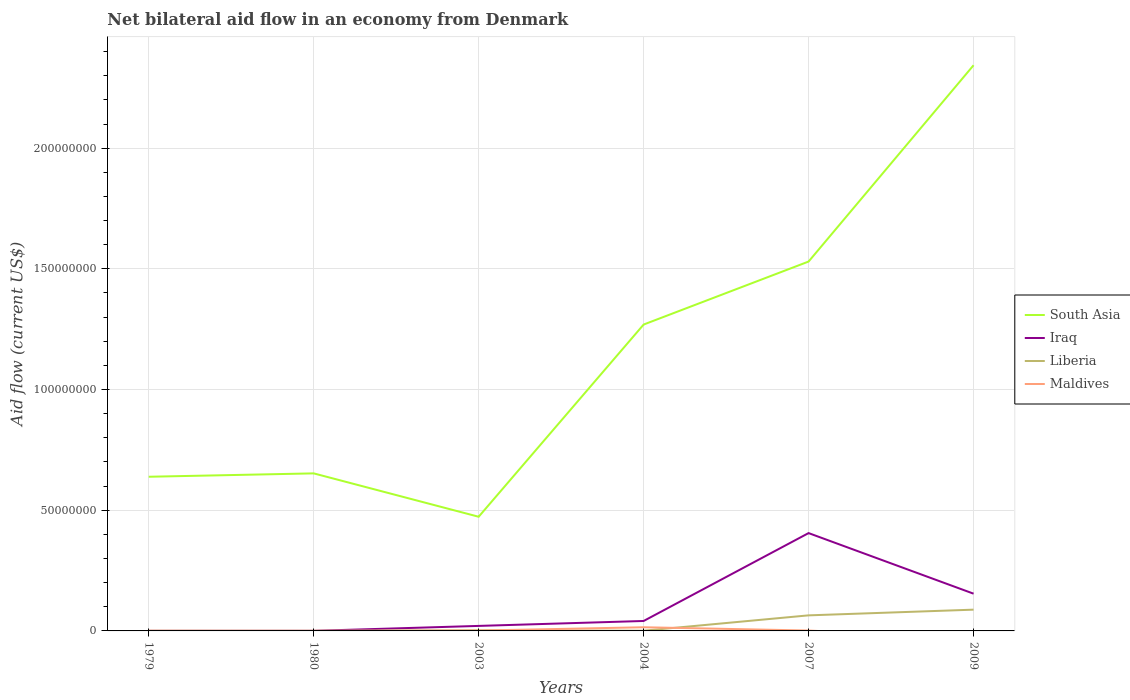Is the number of lines equal to the number of legend labels?
Offer a terse response. No. Across all years, what is the maximum net bilateral aid flow in Iraq?
Offer a terse response. 2.00e+04. What is the total net bilateral aid flow in Liberia in the graph?
Ensure brevity in your answer.  -8.56e+06. What is the difference between the highest and the second highest net bilateral aid flow in South Asia?
Give a very brief answer. 1.87e+08. Is the net bilateral aid flow in Maldives strictly greater than the net bilateral aid flow in South Asia over the years?
Make the answer very short. Yes. How many years are there in the graph?
Make the answer very short. 6. Where does the legend appear in the graph?
Your response must be concise. Center right. How are the legend labels stacked?
Your answer should be compact. Vertical. What is the title of the graph?
Keep it short and to the point. Net bilateral aid flow in an economy from Denmark. What is the Aid flow (current US$) in South Asia in 1979?
Provide a short and direct response. 6.39e+07. What is the Aid flow (current US$) of Iraq in 1979?
Make the answer very short. 2.00e+04. What is the Aid flow (current US$) in Liberia in 1979?
Give a very brief answer. 3.00e+04. What is the Aid flow (current US$) of South Asia in 1980?
Offer a terse response. 6.53e+07. What is the Aid flow (current US$) in Maldives in 1980?
Ensure brevity in your answer.  4.00e+04. What is the Aid flow (current US$) in South Asia in 2003?
Make the answer very short. 4.73e+07. What is the Aid flow (current US$) of Iraq in 2003?
Offer a very short reply. 2.08e+06. What is the Aid flow (current US$) of Liberia in 2003?
Provide a succinct answer. 2.50e+05. What is the Aid flow (current US$) of South Asia in 2004?
Your answer should be very brief. 1.27e+08. What is the Aid flow (current US$) in Iraq in 2004?
Provide a succinct answer. 4.12e+06. What is the Aid flow (current US$) of Maldives in 2004?
Offer a very short reply. 1.52e+06. What is the Aid flow (current US$) in South Asia in 2007?
Ensure brevity in your answer.  1.53e+08. What is the Aid flow (current US$) of Iraq in 2007?
Offer a very short reply. 4.05e+07. What is the Aid flow (current US$) in Liberia in 2007?
Offer a terse response. 6.45e+06. What is the Aid flow (current US$) in Maldives in 2007?
Offer a very short reply. 1.60e+05. What is the Aid flow (current US$) of South Asia in 2009?
Ensure brevity in your answer.  2.34e+08. What is the Aid flow (current US$) in Iraq in 2009?
Your response must be concise. 1.54e+07. What is the Aid flow (current US$) in Liberia in 2009?
Your response must be concise. 8.81e+06. What is the Aid flow (current US$) of Maldives in 2009?
Your answer should be very brief. 0. Across all years, what is the maximum Aid flow (current US$) of South Asia?
Keep it short and to the point. 2.34e+08. Across all years, what is the maximum Aid flow (current US$) of Iraq?
Offer a very short reply. 4.05e+07. Across all years, what is the maximum Aid flow (current US$) of Liberia?
Provide a succinct answer. 8.81e+06. Across all years, what is the maximum Aid flow (current US$) in Maldives?
Your answer should be compact. 1.52e+06. Across all years, what is the minimum Aid flow (current US$) of South Asia?
Provide a short and direct response. 4.73e+07. Across all years, what is the minimum Aid flow (current US$) of Liberia?
Offer a very short reply. 2.00e+04. What is the total Aid flow (current US$) in South Asia in the graph?
Your answer should be very brief. 6.91e+08. What is the total Aid flow (current US$) of Iraq in the graph?
Offer a terse response. 6.22e+07. What is the total Aid flow (current US$) of Liberia in the graph?
Ensure brevity in your answer.  1.56e+07. What is the total Aid flow (current US$) in Maldives in the graph?
Your answer should be very brief. 1.93e+06. What is the difference between the Aid flow (current US$) of South Asia in 1979 and that in 1980?
Give a very brief answer. -1.40e+06. What is the difference between the Aid flow (current US$) of Maldives in 1979 and that in 1980?
Make the answer very short. 3.00e+04. What is the difference between the Aid flow (current US$) in South Asia in 1979 and that in 2003?
Make the answer very short. 1.66e+07. What is the difference between the Aid flow (current US$) of Iraq in 1979 and that in 2003?
Provide a succinct answer. -2.06e+06. What is the difference between the Aid flow (current US$) in Liberia in 1979 and that in 2003?
Offer a very short reply. -2.20e+05. What is the difference between the Aid flow (current US$) of Maldives in 1979 and that in 2003?
Make the answer very short. -7.00e+04. What is the difference between the Aid flow (current US$) in South Asia in 1979 and that in 2004?
Ensure brevity in your answer.  -6.31e+07. What is the difference between the Aid flow (current US$) in Iraq in 1979 and that in 2004?
Keep it short and to the point. -4.10e+06. What is the difference between the Aid flow (current US$) in Maldives in 1979 and that in 2004?
Give a very brief answer. -1.45e+06. What is the difference between the Aid flow (current US$) of South Asia in 1979 and that in 2007?
Provide a short and direct response. -8.92e+07. What is the difference between the Aid flow (current US$) in Iraq in 1979 and that in 2007?
Your answer should be compact. -4.05e+07. What is the difference between the Aid flow (current US$) of Liberia in 1979 and that in 2007?
Make the answer very short. -6.42e+06. What is the difference between the Aid flow (current US$) in Maldives in 1979 and that in 2007?
Provide a succinct answer. -9.00e+04. What is the difference between the Aid flow (current US$) in South Asia in 1979 and that in 2009?
Provide a short and direct response. -1.70e+08. What is the difference between the Aid flow (current US$) in Iraq in 1979 and that in 2009?
Ensure brevity in your answer.  -1.54e+07. What is the difference between the Aid flow (current US$) of Liberia in 1979 and that in 2009?
Ensure brevity in your answer.  -8.78e+06. What is the difference between the Aid flow (current US$) of South Asia in 1980 and that in 2003?
Make the answer very short. 1.80e+07. What is the difference between the Aid flow (current US$) of Iraq in 1980 and that in 2003?
Keep it short and to the point. -2.05e+06. What is the difference between the Aid flow (current US$) of Liberia in 1980 and that in 2003?
Offer a very short reply. -2.30e+05. What is the difference between the Aid flow (current US$) in South Asia in 1980 and that in 2004?
Offer a terse response. -6.17e+07. What is the difference between the Aid flow (current US$) of Iraq in 1980 and that in 2004?
Your answer should be very brief. -4.09e+06. What is the difference between the Aid flow (current US$) of Maldives in 1980 and that in 2004?
Keep it short and to the point. -1.48e+06. What is the difference between the Aid flow (current US$) in South Asia in 1980 and that in 2007?
Your response must be concise. -8.78e+07. What is the difference between the Aid flow (current US$) of Iraq in 1980 and that in 2007?
Offer a very short reply. -4.05e+07. What is the difference between the Aid flow (current US$) in Liberia in 1980 and that in 2007?
Keep it short and to the point. -6.43e+06. What is the difference between the Aid flow (current US$) of South Asia in 1980 and that in 2009?
Ensure brevity in your answer.  -1.69e+08. What is the difference between the Aid flow (current US$) of Iraq in 1980 and that in 2009?
Provide a short and direct response. -1.54e+07. What is the difference between the Aid flow (current US$) in Liberia in 1980 and that in 2009?
Provide a short and direct response. -8.79e+06. What is the difference between the Aid flow (current US$) in South Asia in 2003 and that in 2004?
Offer a terse response. -7.96e+07. What is the difference between the Aid flow (current US$) of Iraq in 2003 and that in 2004?
Your answer should be very brief. -2.04e+06. What is the difference between the Aid flow (current US$) of Liberia in 2003 and that in 2004?
Keep it short and to the point. 1.60e+05. What is the difference between the Aid flow (current US$) of Maldives in 2003 and that in 2004?
Your response must be concise. -1.38e+06. What is the difference between the Aid flow (current US$) in South Asia in 2003 and that in 2007?
Provide a succinct answer. -1.06e+08. What is the difference between the Aid flow (current US$) of Iraq in 2003 and that in 2007?
Your answer should be compact. -3.84e+07. What is the difference between the Aid flow (current US$) of Liberia in 2003 and that in 2007?
Offer a very short reply. -6.20e+06. What is the difference between the Aid flow (current US$) of South Asia in 2003 and that in 2009?
Keep it short and to the point. -1.87e+08. What is the difference between the Aid flow (current US$) of Iraq in 2003 and that in 2009?
Offer a terse response. -1.34e+07. What is the difference between the Aid flow (current US$) of Liberia in 2003 and that in 2009?
Your answer should be very brief. -8.56e+06. What is the difference between the Aid flow (current US$) of South Asia in 2004 and that in 2007?
Offer a terse response. -2.61e+07. What is the difference between the Aid flow (current US$) in Iraq in 2004 and that in 2007?
Ensure brevity in your answer.  -3.64e+07. What is the difference between the Aid flow (current US$) in Liberia in 2004 and that in 2007?
Offer a very short reply. -6.36e+06. What is the difference between the Aid flow (current US$) in Maldives in 2004 and that in 2007?
Your response must be concise. 1.36e+06. What is the difference between the Aid flow (current US$) in South Asia in 2004 and that in 2009?
Give a very brief answer. -1.07e+08. What is the difference between the Aid flow (current US$) of Iraq in 2004 and that in 2009?
Provide a short and direct response. -1.13e+07. What is the difference between the Aid flow (current US$) of Liberia in 2004 and that in 2009?
Offer a very short reply. -8.72e+06. What is the difference between the Aid flow (current US$) of South Asia in 2007 and that in 2009?
Give a very brief answer. -8.13e+07. What is the difference between the Aid flow (current US$) of Iraq in 2007 and that in 2009?
Ensure brevity in your answer.  2.51e+07. What is the difference between the Aid flow (current US$) in Liberia in 2007 and that in 2009?
Provide a succinct answer. -2.36e+06. What is the difference between the Aid flow (current US$) of South Asia in 1979 and the Aid flow (current US$) of Iraq in 1980?
Keep it short and to the point. 6.38e+07. What is the difference between the Aid flow (current US$) in South Asia in 1979 and the Aid flow (current US$) in Liberia in 1980?
Ensure brevity in your answer.  6.38e+07. What is the difference between the Aid flow (current US$) of South Asia in 1979 and the Aid flow (current US$) of Maldives in 1980?
Give a very brief answer. 6.38e+07. What is the difference between the Aid flow (current US$) in Liberia in 1979 and the Aid flow (current US$) in Maldives in 1980?
Your answer should be very brief. -10000. What is the difference between the Aid flow (current US$) of South Asia in 1979 and the Aid flow (current US$) of Iraq in 2003?
Offer a very short reply. 6.18e+07. What is the difference between the Aid flow (current US$) of South Asia in 1979 and the Aid flow (current US$) of Liberia in 2003?
Keep it short and to the point. 6.36e+07. What is the difference between the Aid flow (current US$) of South Asia in 1979 and the Aid flow (current US$) of Maldives in 2003?
Your answer should be very brief. 6.37e+07. What is the difference between the Aid flow (current US$) of South Asia in 1979 and the Aid flow (current US$) of Iraq in 2004?
Your answer should be compact. 5.98e+07. What is the difference between the Aid flow (current US$) of South Asia in 1979 and the Aid flow (current US$) of Liberia in 2004?
Provide a short and direct response. 6.38e+07. What is the difference between the Aid flow (current US$) of South Asia in 1979 and the Aid flow (current US$) of Maldives in 2004?
Your answer should be very brief. 6.24e+07. What is the difference between the Aid flow (current US$) in Iraq in 1979 and the Aid flow (current US$) in Liberia in 2004?
Keep it short and to the point. -7.00e+04. What is the difference between the Aid flow (current US$) of Iraq in 1979 and the Aid flow (current US$) of Maldives in 2004?
Your response must be concise. -1.50e+06. What is the difference between the Aid flow (current US$) of Liberia in 1979 and the Aid flow (current US$) of Maldives in 2004?
Make the answer very short. -1.49e+06. What is the difference between the Aid flow (current US$) of South Asia in 1979 and the Aid flow (current US$) of Iraq in 2007?
Give a very brief answer. 2.33e+07. What is the difference between the Aid flow (current US$) in South Asia in 1979 and the Aid flow (current US$) in Liberia in 2007?
Provide a short and direct response. 5.74e+07. What is the difference between the Aid flow (current US$) in South Asia in 1979 and the Aid flow (current US$) in Maldives in 2007?
Give a very brief answer. 6.37e+07. What is the difference between the Aid flow (current US$) of Iraq in 1979 and the Aid flow (current US$) of Liberia in 2007?
Your response must be concise. -6.43e+06. What is the difference between the Aid flow (current US$) of South Asia in 1979 and the Aid flow (current US$) of Iraq in 2009?
Your answer should be very brief. 4.84e+07. What is the difference between the Aid flow (current US$) of South Asia in 1979 and the Aid flow (current US$) of Liberia in 2009?
Your response must be concise. 5.51e+07. What is the difference between the Aid flow (current US$) in Iraq in 1979 and the Aid flow (current US$) in Liberia in 2009?
Offer a very short reply. -8.79e+06. What is the difference between the Aid flow (current US$) of South Asia in 1980 and the Aid flow (current US$) of Iraq in 2003?
Your answer should be compact. 6.32e+07. What is the difference between the Aid flow (current US$) in South Asia in 1980 and the Aid flow (current US$) in Liberia in 2003?
Your answer should be very brief. 6.50e+07. What is the difference between the Aid flow (current US$) in South Asia in 1980 and the Aid flow (current US$) in Maldives in 2003?
Ensure brevity in your answer.  6.51e+07. What is the difference between the Aid flow (current US$) in Iraq in 1980 and the Aid flow (current US$) in Liberia in 2003?
Provide a short and direct response. -2.20e+05. What is the difference between the Aid flow (current US$) of Iraq in 1980 and the Aid flow (current US$) of Maldives in 2003?
Provide a short and direct response. -1.10e+05. What is the difference between the Aid flow (current US$) of South Asia in 1980 and the Aid flow (current US$) of Iraq in 2004?
Your answer should be compact. 6.12e+07. What is the difference between the Aid flow (current US$) in South Asia in 1980 and the Aid flow (current US$) in Liberia in 2004?
Provide a short and direct response. 6.52e+07. What is the difference between the Aid flow (current US$) in South Asia in 1980 and the Aid flow (current US$) in Maldives in 2004?
Offer a very short reply. 6.38e+07. What is the difference between the Aid flow (current US$) in Iraq in 1980 and the Aid flow (current US$) in Maldives in 2004?
Make the answer very short. -1.49e+06. What is the difference between the Aid flow (current US$) in Liberia in 1980 and the Aid flow (current US$) in Maldives in 2004?
Provide a short and direct response. -1.50e+06. What is the difference between the Aid flow (current US$) in South Asia in 1980 and the Aid flow (current US$) in Iraq in 2007?
Keep it short and to the point. 2.47e+07. What is the difference between the Aid flow (current US$) of South Asia in 1980 and the Aid flow (current US$) of Liberia in 2007?
Ensure brevity in your answer.  5.88e+07. What is the difference between the Aid flow (current US$) of South Asia in 1980 and the Aid flow (current US$) of Maldives in 2007?
Ensure brevity in your answer.  6.51e+07. What is the difference between the Aid flow (current US$) in Iraq in 1980 and the Aid flow (current US$) in Liberia in 2007?
Your response must be concise. -6.42e+06. What is the difference between the Aid flow (current US$) in Iraq in 1980 and the Aid flow (current US$) in Maldives in 2007?
Make the answer very short. -1.30e+05. What is the difference between the Aid flow (current US$) in Liberia in 1980 and the Aid flow (current US$) in Maldives in 2007?
Make the answer very short. -1.40e+05. What is the difference between the Aid flow (current US$) in South Asia in 1980 and the Aid flow (current US$) in Iraq in 2009?
Make the answer very short. 4.98e+07. What is the difference between the Aid flow (current US$) in South Asia in 1980 and the Aid flow (current US$) in Liberia in 2009?
Provide a succinct answer. 5.65e+07. What is the difference between the Aid flow (current US$) of Iraq in 1980 and the Aid flow (current US$) of Liberia in 2009?
Offer a terse response. -8.78e+06. What is the difference between the Aid flow (current US$) in South Asia in 2003 and the Aid flow (current US$) in Iraq in 2004?
Keep it short and to the point. 4.32e+07. What is the difference between the Aid flow (current US$) of South Asia in 2003 and the Aid flow (current US$) of Liberia in 2004?
Provide a succinct answer. 4.72e+07. What is the difference between the Aid flow (current US$) in South Asia in 2003 and the Aid flow (current US$) in Maldives in 2004?
Provide a short and direct response. 4.58e+07. What is the difference between the Aid flow (current US$) in Iraq in 2003 and the Aid flow (current US$) in Liberia in 2004?
Your response must be concise. 1.99e+06. What is the difference between the Aid flow (current US$) of Iraq in 2003 and the Aid flow (current US$) of Maldives in 2004?
Keep it short and to the point. 5.60e+05. What is the difference between the Aid flow (current US$) of Liberia in 2003 and the Aid flow (current US$) of Maldives in 2004?
Ensure brevity in your answer.  -1.27e+06. What is the difference between the Aid flow (current US$) of South Asia in 2003 and the Aid flow (current US$) of Iraq in 2007?
Give a very brief answer. 6.77e+06. What is the difference between the Aid flow (current US$) of South Asia in 2003 and the Aid flow (current US$) of Liberia in 2007?
Your answer should be compact. 4.08e+07. What is the difference between the Aid flow (current US$) in South Asia in 2003 and the Aid flow (current US$) in Maldives in 2007?
Ensure brevity in your answer.  4.71e+07. What is the difference between the Aid flow (current US$) of Iraq in 2003 and the Aid flow (current US$) of Liberia in 2007?
Provide a short and direct response. -4.37e+06. What is the difference between the Aid flow (current US$) of Iraq in 2003 and the Aid flow (current US$) of Maldives in 2007?
Offer a terse response. 1.92e+06. What is the difference between the Aid flow (current US$) in South Asia in 2003 and the Aid flow (current US$) in Iraq in 2009?
Give a very brief answer. 3.19e+07. What is the difference between the Aid flow (current US$) in South Asia in 2003 and the Aid flow (current US$) in Liberia in 2009?
Your answer should be compact. 3.85e+07. What is the difference between the Aid flow (current US$) of Iraq in 2003 and the Aid flow (current US$) of Liberia in 2009?
Make the answer very short. -6.73e+06. What is the difference between the Aid flow (current US$) of South Asia in 2004 and the Aid flow (current US$) of Iraq in 2007?
Provide a short and direct response. 8.64e+07. What is the difference between the Aid flow (current US$) in South Asia in 2004 and the Aid flow (current US$) in Liberia in 2007?
Your answer should be compact. 1.20e+08. What is the difference between the Aid flow (current US$) in South Asia in 2004 and the Aid flow (current US$) in Maldives in 2007?
Provide a short and direct response. 1.27e+08. What is the difference between the Aid flow (current US$) of Iraq in 2004 and the Aid flow (current US$) of Liberia in 2007?
Your answer should be compact. -2.33e+06. What is the difference between the Aid flow (current US$) of Iraq in 2004 and the Aid flow (current US$) of Maldives in 2007?
Offer a terse response. 3.96e+06. What is the difference between the Aid flow (current US$) in Liberia in 2004 and the Aid flow (current US$) in Maldives in 2007?
Your answer should be compact. -7.00e+04. What is the difference between the Aid flow (current US$) in South Asia in 2004 and the Aid flow (current US$) in Iraq in 2009?
Your answer should be compact. 1.12e+08. What is the difference between the Aid flow (current US$) of South Asia in 2004 and the Aid flow (current US$) of Liberia in 2009?
Keep it short and to the point. 1.18e+08. What is the difference between the Aid flow (current US$) of Iraq in 2004 and the Aid flow (current US$) of Liberia in 2009?
Provide a short and direct response. -4.69e+06. What is the difference between the Aid flow (current US$) of South Asia in 2007 and the Aid flow (current US$) of Iraq in 2009?
Ensure brevity in your answer.  1.38e+08. What is the difference between the Aid flow (current US$) in South Asia in 2007 and the Aid flow (current US$) in Liberia in 2009?
Offer a very short reply. 1.44e+08. What is the difference between the Aid flow (current US$) in Iraq in 2007 and the Aid flow (current US$) in Liberia in 2009?
Provide a succinct answer. 3.17e+07. What is the average Aid flow (current US$) in South Asia per year?
Your response must be concise. 1.15e+08. What is the average Aid flow (current US$) in Iraq per year?
Offer a very short reply. 1.04e+07. What is the average Aid flow (current US$) in Liberia per year?
Offer a very short reply. 2.61e+06. What is the average Aid flow (current US$) of Maldives per year?
Provide a succinct answer. 3.22e+05. In the year 1979, what is the difference between the Aid flow (current US$) of South Asia and Aid flow (current US$) of Iraq?
Make the answer very short. 6.38e+07. In the year 1979, what is the difference between the Aid flow (current US$) in South Asia and Aid flow (current US$) in Liberia?
Keep it short and to the point. 6.38e+07. In the year 1979, what is the difference between the Aid flow (current US$) of South Asia and Aid flow (current US$) of Maldives?
Ensure brevity in your answer.  6.38e+07. In the year 1979, what is the difference between the Aid flow (current US$) of Iraq and Aid flow (current US$) of Liberia?
Your answer should be compact. -10000. In the year 1979, what is the difference between the Aid flow (current US$) of Liberia and Aid flow (current US$) of Maldives?
Make the answer very short. -4.00e+04. In the year 1980, what is the difference between the Aid flow (current US$) in South Asia and Aid flow (current US$) in Iraq?
Your answer should be compact. 6.52e+07. In the year 1980, what is the difference between the Aid flow (current US$) of South Asia and Aid flow (current US$) of Liberia?
Ensure brevity in your answer.  6.52e+07. In the year 1980, what is the difference between the Aid flow (current US$) of South Asia and Aid flow (current US$) of Maldives?
Offer a very short reply. 6.52e+07. In the year 1980, what is the difference between the Aid flow (current US$) of Iraq and Aid flow (current US$) of Liberia?
Your answer should be very brief. 10000. In the year 1980, what is the difference between the Aid flow (current US$) of Iraq and Aid flow (current US$) of Maldives?
Offer a very short reply. -10000. In the year 2003, what is the difference between the Aid flow (current US$) in South Asia and Aid flow (current US$) in Iraq?
Give a very brief answer. 4.52e+07. In the year 2003, what is the difference between the Aid flow (current US$) of South Asia and Aid flow (current US$) of Liberia?
Make the answer very short. 4.70e+07. In the year 2003, what is the difference between the Aid flow (current US$) of South Asia and Aid flow (current US$) of Maldives?
Your answer should be compact. 4.72e+07. In the year 2003, what is the difference between the Aid flow (current US$) in Iraq and Aid flow (current US$) in Liberia?
Keep it short and to the point. 1.83e+06. In the year 2003, what is the difference between the Aid flow (current US$) in Iraq and Aid flow (current US$) in Maldives?
Offer a very short reply. 1.94e+06. In the year 2004, what is the difference between the Aid flow (current US$) in South Asia and Aid flow (current US$) in Iraq?
Provide a succinct answer. 1.23e+08. In the year 2004, what is the difference between the Aid flow (current US$) of South Asia and Aid flow (current US$) of Liberia?
Your answer should be compact. 1.27e+08. In the year 2004, what is the difference between the Aid flow (current US$) of South Asia and Aid flow (current US$) of Maldives?
Provide a short and direct response. 1.25e+08. In the year 2004, what is the difference between the Aid flow (current US$) in Iraq and Aid flow (current US$) in Liberia?
Keep it short and to the point. 4.03e+06. In the year 2004, what is the difference between the Aid flow (current US$) in Iraq and Aid flow (current US$) in Maldives?
Your response must be concise. 2.60e+06. In the year 2004, what is the difference between the Aid flow (current US$) of Liberia and Aid flow (current US$) of Maldives?
Ensure brevity in your answer.  -1.43e+06. In the year 2007, what is the difference between the Aid flow (current US$) in South Asia and Aid flow (current US$) in Iraq?
Provide a short and direct response. 1.12e+08. In the year 2007, what is the difference between the Aid flow (current US$) in South Asia and Aid flow (current US$) in Liberia?
Give a very brief answer. 1.47e+08. In the year 2007, what is the difference between the Aid flow (current US$) in South Asia and Aid flow (current US$) in Maldives?
Offer a terse response. 1.53e+08. In the year 2007, what is the difference between the Aid flow (current US$) of Iraq and Aid flow (current US$) of Liberia?
Offer a very short reply. 3.41e+07. In the year 2007, what is the difference between the Aid flow (current US$) of Iraq and Aid flow (current US$) of Maldives?
Provide a succinct answer. 4.04e+07. In the year 2007, what is the difference between the Aid flow (current US$) in Liberia and Aid flow (current US$) in Maldives?
Keep it short and to the point. 6.29e+06. In the year 2009, what is the difference between the Aid flow (current US$) in South Asia and Aid flow (current US$) in Iraq?
Ensure brevity in your answer.  2.19e+08. In the year 2009, what is the difference between the Aid flow (current US$) of South Asia and Aid flow (current US$) of Liberia?
Provide a succinct answer. 2.26e+08. In the year 2009, what is the difference between the Aid flow (current US$) of Iraq and Aid flow (current US$) of Liberia?
Make the answer very short. 6.62e+06. What is the ratio of the Aid flow (current US$) in South Asia in 1979 to that in 1980?
Your answer should be compact. 0.98. What is the ratio of the Aid flow (current US$) of Liberia in 1979 to that in 1980?
Offer a very short reply. 1.5. What is the ratio of the Aid flow (current US$) of South Asia in 1979 to that in 2003?
Provide a succinct answer. 1.35. What is the ratio of the Aid flow (current US$) in Iraq in 1979 to that in 2003?
Make the answer very short. 0.01. What is the ratio of the Aid flow (current US$) in Liberia in 1979 to that in 2003?
Provide a short and direct response. 0.12. What is the ratio of the Aid flow (current US$) of Maldives in 1979 to that in 2003?
Offer a terse response. 0.5. What is the ratio of the Aid flow (current US$) in South Asia in 1979 to that in 2004?
Provide a short and direct response. 0.5. What is the ratio of the Aid flow (current US$) of Iraq in 1979 to that in 2004?
Ensure brevity in your answer.  0. What is the ratio of the Aid flow (current US$) in Maldives in 1979 to that in 2004?
Give a very brief answer. 0.05. What is the ratio of the Aid flow (current US$) of South Asia in 1979 to that in 2007?
Your answer should be very brief. 0.42. What is the ratio of the Aid flow (current US$) of Liberia in 1979 to that in 2007?
Keep it short and to the point. 0. What is the ratio of the Aid flow (current US$) in Maldives in 1979 to that in 2007?
Offer a very short reply. 0.44. What is the ratio of the Aid flow (current US$) in South Asia in 1979 to that in 2009?
Offer a very short reply. 0.27. What is the ratio of the Aid flow (current US$) of Iraq in 1979 to that in 2009?
Keep it short and to the point. 0. What is the ratio of the Aid flow (current US$) in Liberia in 1979 to that in 2009?
Ensure brevity in your answer.  0. What is the ratio of the Aid flow (current US$) in South Asia in 1980 to that in 2003?
Your answer should be compact. 1.38. What is the ratio of the Aid flow (current US$) of Iraq in 1980 to that in 2003?
Provide a short and direct response. 0.01. What is the ratio of the Aid flow (current US$) in Maldives in 1980 to that in 2003?
Your answer should be compact. 0.29. What is the ratio of the Aid flow (current US$) in South Asia in 1980 to that in 2004?
Your response must be concise. 0.51. What is the ratio of the Aid flow (current US$) in Iraq in 1980 to that in 2004?
Give a very brief answer. 0.01. What is the ratio of the Aid flow (current US$) of Liberia in 1980 to that in 2004?
Offer a very short reply. 0.22. What is the ratio of the Aid flow (current US$) of Maldives in 1980 to that in 2004?
Your response must be concise. 0.03. What is the ratio of the Aid flow (current US$) in South Asia in 1980 to that in 2007?
Ensure brevity in your answer.  0.43. What is the ratio of the Aid flow (current US$) in Iraq in 1980 to that in 2007?
Offer a very short reply. 0. What is the ratio of the Aid flow (current US$) in Liberia in 1980 to that in 2007?
Provide a short and direct response. 0. What is the ratio of the Aid flow (current US$) of South Asia in 1980 to that in 2009?
Give a very brief answer. 0.28. What is the ratio of the Aid flow (current US$) of Iraq in 1980 to that in 2009?
Provide a short and direct response. 0. What is the ratio of the Aid flow (current US$) in Liberia in 1980 to that in 2009?
Offer a terse response. 0. What is the ratio of the Aid flow (current US$) in South Asia in 2003 to that in 2004?
Make the answer very short. 0.37. What is the ratio of the Aid flow (current US$) in Iraq in 2003 to that in 2004?
Give a very brief answer. 0.5. What is the ratio of the Aid flow (current US$) in Liberia in 2003 to that in 2004?
Ensure brevity in your answer.  2.78. What is the ratio of the Aid flow (current US$) in Maldives in 2003 to that in 2004?
Your response must be concise. 0.09. What is the ratio of the Aid flow (current US$) of South Asia in 2003 to that in 2007?
Offer a very short reply. 0.31. What is the ratio of the Aid flow (current US$) of Iraq in 2003 to that in 2007?
Make the answer very short. 0.05. What is the ratio of the Aid flow (current US$) in Liberia in 2003 to that in 2007?
Your answer should be very brief. 0.04. What is the ratio of the Aid flow (current US$) of South Asia in 2003 to that in 2009?
Ensure brevity in your answer.  0.2. What is the ratio of the Aid flow (current US$) of Iraq in 2003 to that in 2009?
Keep it short and to the point. 0.13. What is the ratio of the Aid flow (current US$) in Liberia in 2003 to that in 2009?
Offer a terse response. 0.03. What is the ratio of the Aid flow (current US$) of South Asia in 2004 to that in 2007?
Offer a terse response. 0.83. What is the ratio of the Aid flow (current US$) of Iraq in 2004 to that in 2007?
Make the answer very short. 0.1. What is the ratio of the Aid flow (current US$) in Liberia in 2004 to that in 2007?
Keep it short and to the point. 0.01. What is the ratio of the Aid flow (current US$) of Maldives in 2004 to that in 2007?
Ensure brevity in your answer.  9.5. What is the ratio of the Aid flow (current US$) of South Asia in 2004 to that in 2009?
Ensure brevity in your answer.  0.54. What is the ratio of the Aid flow (current US$) of Iraq in 2004 to that in 2009?
Make the answer very short. 0.27. What is the ratio of the Aid flow (current US$) in Liberia in 2004 to that in 2009?
Provide a succinct answer. 0.01. What is the ratio of the Aid flow (current US$) of South Asia in 2007 to that in 2009?
Offer a terse response. 0.65. What is the ratio of the Aid flow (current US$) of Iraq in 2007 to that in 2009?
Provide a short and direct response. 2.63. What is the ratio of the Aid flow (current US$) of Liberia in 2007 to that in 2009?
Give a very brief answer. 0.73. What is the difference between the highest and the second highest Aid flow (current US$) in South Asia?
Provide a succinct answer. 8.13e+07. What is the difference between the highest and the second highest Aid flow (current US$) in Iraq?
Your response must be concise. 2.51e+07. What is the difference between the highest and the second highest Aid flow (current US$) in Liberia?
Provide a succinct answer. 2.36e+06. What is the difference between the highest and the second highest Aid flow (current US$) of Maldives?
Offer a terse response. 1.36e+06. What is the difference between the highest and the lowest Aid flow (current US$) in South Asia?
Your answer should be very brief. 1.87e+08. What is the difference between the highest and the lowest Aid flow (current US$) of Iraq?
Offer a very short reply. 4.05e+07. What is the difference between the highest and the lowest Aid flow (current US$) of Liberia?
Offer a very short reply. 8.79e+06. What is the difference between the highest and the lowest Aid flow (current US$) in Maldives?
Provide a succinct answer. 1.52e+06. 